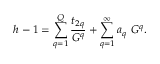Convert formula to latex. <formula><loc_0><loc_0><loc_500><loc_500>h - 1 = \sum _ { q = 1 } ^ { Q } { \frac { t _ { 2 q } } { G ^ { q } } } + \sum _ { q = 1 } ^ { \infty } a _ { q } G ^ { q } .</formula> 